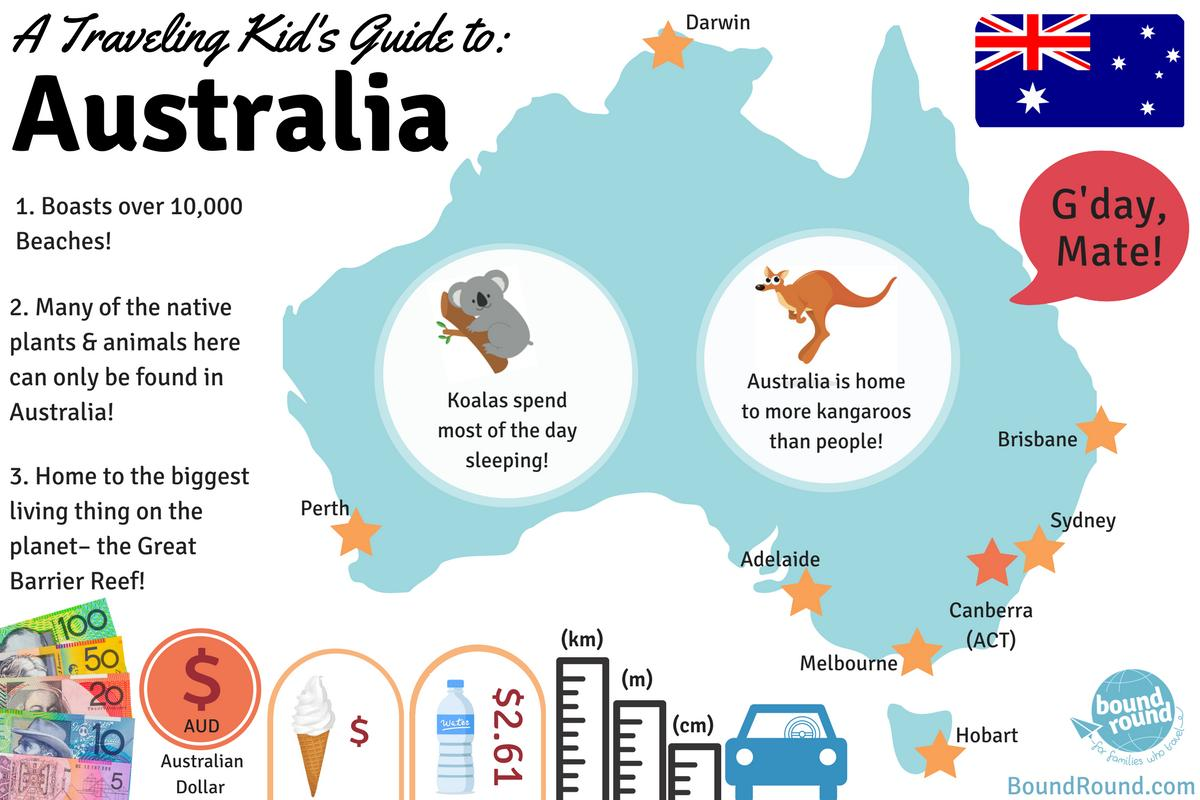Draw attention to some important aspects in this diagram. The average cost of bottled water in Australia is $2.61 per litre. The city marked on the south-west coast is Perth. The city marked on the island is Hobart. The city of Darwin is marked in the north. The kangaroo is the national animal of Australia. 